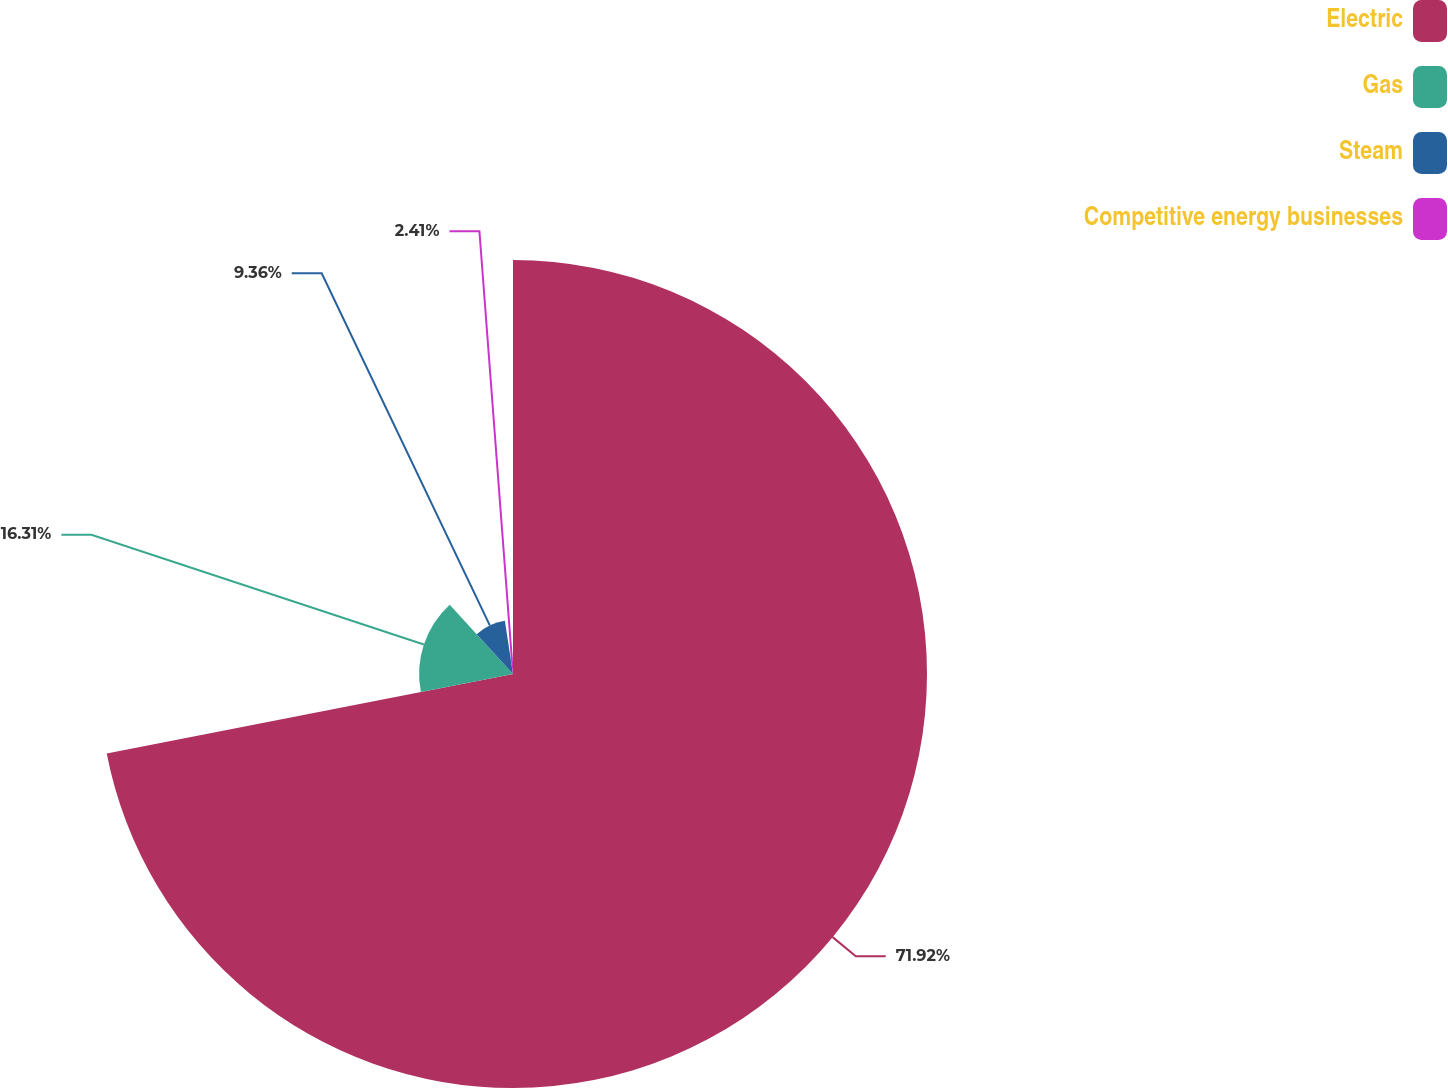Convert chart. <chart><loc_0><loc_0><loc_500><loc_500><pie_chart><fcel>Electric<fcel>Gas<fcel>Steam<fcel>Competitive energy businesses<nl><fcel>71.93%<fcel>16.31%<fcel>9.36%<fcel>2.41%<nl></chart> 